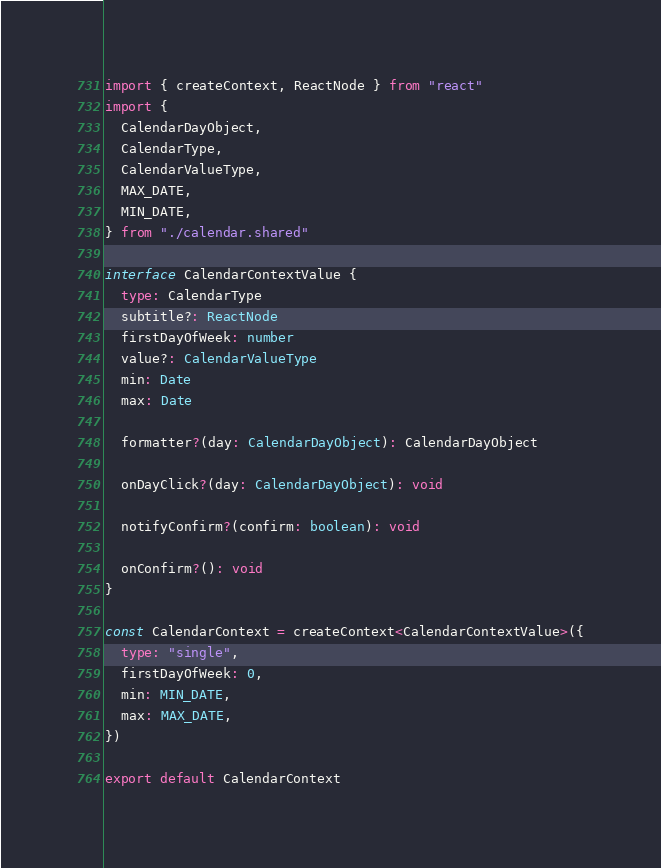<code> <loc_0><loc_0><loc_500><loc_500><_TypeScript_>import { createContext, ReactNode } from "react"
import {
  CalendarDayObject,
  CalendarType,
  CalendarValueType,
  MAX_DATE,
  MIN_DATE,
} from "./calendar.shared"

interface CalendarContextValue {
  type: CalendarType
  subtitle?: ReactNode
  firstDayOfWeek: number
  value?: CalendarValueType
  min: Date
  max: Date

  formatter?(day: CalendarDayObject): CalendarDayObject

  onDayClick?(day: CalendarDayObject): void

  notifyConfirm?(confirm: boolean): void

  onConfirm?(): void
}

const CalendarContext = createContext<CalendarContextValue>({
  type: "single",
  firstDayOfWeek: 0,
  min: MIN_DATE,
  max: MAX_DATE,
})

export default CalendarContext
</code> 